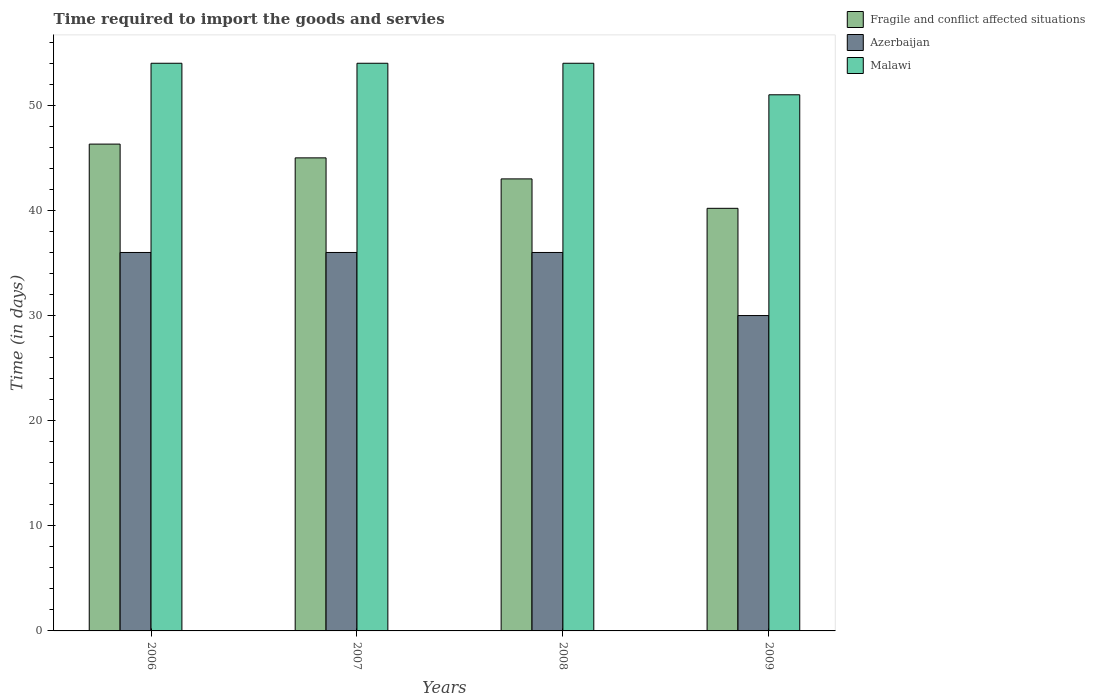How many groups of bars are there?
Provide a succinct answer. 4. Are the number of bars per tick equal to the number of legend labels?
Your answer should be very brief. Yes. How many bars are there on the 4th tick from the left?
Your response must be concise. 3. What is the label of the 1st group of bars from the left?
Your answer should be very brief. 2006. Across all years, what is the maximum number of days required to import the goods and services in Malawi?
Offer a terse response. 54. Across all years, what is the minimum number of days required to import the goods and services in Azerbaijan?
Give a very brief answer. 30. In which year was the number of days required to import the goods and services in Fragile and conflict affected situations maximum?
Offer a very short reply. 2006. What is the total number of days required to import the goods and services in Malawi in the graph?
Keep it short and to the point. 213. What is the difference between the number of days required to import the goods and services in Fragile and conflict affected situations in 2006 and that in 2007?
Provide a short and direct response. 1.31. What is the difference between the number of days required to import the goods and services in Fragile and conflict affected situations in 2009 and the number of days required to import the goods and services in Azerbaijan in 2006?
Your answer should be very brief. 4.2. What is the average number of days required to import the goods and services in Azerbaijan per year?
Offer a very short reply. 34.5. In the year 2007, what is the difference between the number of days required to import the goods and services in Fragile and conflict affected situations and number of days required to import the goods and services in Malawi?
Keep it short and to the point. -9. Is the difference between the number of days required to import the goods and services in Fragile and conflict affected situations in 2007 and 2008 greater than the difference between the number of days required to import the goods and services in Malawi in 2007 and 2008?
Your answer should be very brief. Yes. What is the difference between the highest and the second highest number of days required to import the goods and services in Fragile and conflict affected situations?
Offer a very short reply. 1.31. What is the difference between the highest and the lowest number of days required to import the goods and services in Malawi?
Provide a short and direct response. 3. What does the 3rd bar from the left in 2006 represents?
Give a very brief answer. Malawi. What does the 1st bar from the right in 2007 represents?
Make the answer very short. Malawi. Is it the case that in every year, the sum of the number of days required to import the goods and services in Malawi and number of days required to import the goods and services in Fragile and conflict affected situations is greater than the number of days required to import the goods and services in Azerbaijan?
Provide a succinct answer. Yes. How many bars are there?
Ensure brevity in your answer.  12. How many years are there in the graph?
Offer a terse response. 4. What is the difference between two consecutive major ticks on the Y-axis?
Keep it short and to the point. 10. Are the values on the major ticks of Y-axis written in scientific E-notation?
Provide a succinct answer. No. Does the graph contain grids?
Ensure brevity in your answer.  No. Where does the legend appear in the graph?
Your response must be concise. Top right. How are the legend labels stacked?
Offer a very short reply. Vertical. What is the title of the graph?
Make the answer very short. Time required to import the goods and servies. What is the label or title of the X-axis?
Your answer should be very brief. Years. What is the label or title of the Y-axis?
Provide a succinct answer. Time (in days). What is the Time (in days) in Fragile and conflict affected situations in 2006?
Provide a succinct answer. 46.31. What is the Time (in days) of Azerbaijan in 2006?
Provide a succinct answer. 36. What is the Time (in days) in Azerbaijan in 2007?
Ensure brevity in your answer.  36. What is the Time (in days) in Fragile and conflict affected situations in 2009?
Your answer should be very brief. 40.2. What is the Time (in days) of Malawi in 2009?
Your answer should be very brief. 51. Across all years, what is the maximum Time (in days) in Fragile and conflict affected situations?
Make the answer very short. 46.31. Across all years, what is the maximum Time (in days) of Azerbaijan?
Provide a succinct answer. 36. Across all years, what is the maximum Time (in days) in Malawi?
Make the answer very short. 54. Across all years, what is the minimum Time (in days) of Fragile and conflict affected situations?
Make the answer very short. 40.2. Across all years, what is the minimum Time (in days) of Malawi?
Provide a succinct answer. 51. What is the total Time (in days) in Fragile and conflict affected situations in the graph?
Provide a succinct answer. 174.51. What is the total Time (in days) in Azerbaijan in the graph?
Your answer should be compact. 138. What is the total Time (in days) in Malawi in the graph?
Offer a very short reply. 213. What is the difference between the Time (in days) of Fragile and conflict affected situations in 2006 and that in 2007?
Your response must be concise. 1.31. What is the difference between the Time (in days) of Fragile and conflict affected situations in 2006 and that in 2008?
Keep it short and to the point. 3.31. What is the difference between the Time (in days) of Azerbaijan in 2006 and that in 2008?
Ensure brevity in your answer.  0. What is the difference between the Time (in days) of Fragile and conflict affected situations in 2006 and that in 2009?
Offer a very short reply. 6.11. What is the difference between the Time (in days) of Azerbaijan in 2006 and that in 2009?
Your response must be concise. 6. What is the difference between the Time (in days) in Malawi in 2006 and that in 2009?
Give a very brief answer. 3. What is the difference between the Time (in days) of Azerbaijan in 2007 and that in 2008?
Offer a terse response. 0. What is the difference between the Time (in days) in Fragile and conflict affected situations in 2007 and that in 2009?
Your response must be concise. 4.8. What is the difference between the Time (in days) in Fragile and conflict affected situations in 2008 and that in 2009?
Offer a terse response. 2.8. What is the difference between the Time (in days) of Azerbaijan in 2008 and that in 2009?
Offer a terse response. 6. What is the difference between the Time (in days) of Malawi in 2008 and that in 2009?
Ensure brevity in your answer.  3. What is the difference between the Time (in days) in Fragile and conflict affected situations in 2006 and the Time (in days) in Azerbaijan in 2007?
Offer a very short reply. 10.31. What is the difference between the Time (in days) in Fragile and conflict affected situations in 2006 and the Time (in days) in Malawi in 2007?
Provide a succinct answer. -7.69. What is the difference between the Time (in days) in Fragile and conflict affected situations in 2006 and the Time (in days) in Azerbaijan in 2008?
Provide a succinct answer. 10.31. What is the difference between the Time (in days) of Fragile and conflict affected situations in 2006 and the Time (in days) of Malawi in 2008?
Offer a terse response. -7.69. What is the difference between the Time (in days) of Fragile and conflict affected situations in 2006 and the Time (in days) of Azerbaijan in 2009?
Make the answer very short. 16.31. What is the difference between the Time (in days) in Fragile and conflict affected situations in 2006 and the Time (in days) in Malawi in 2009?
Provide a short and direct response. -4.69. What is the difference between the Time (in days) of Fragile and conflict affected situations in 2007 and the Time (in days) of Malawi in 2008?
Offer a terse response. -9. What is the difference between the Time (in days) in Azerbaijan in 2007 and the Time (in days) in Malawi in 2008?
Make the answer very short. -18. What is the difference between the Time (in days) in Fragile and conflict affected situations in 2007 and the Time (in days) in Azerbaijan in 2009?
Give a very brief answer. 15. What is the difference between the Time (in days) of Fragile and conflict affected situations in 2007 and the Time (in days) of Malawi in 2009?
Your response must be concise. -6. What is the difference between the Time (in days) in Azerbaijan in 2007 and the Time (in days) in Malawi in 2009?
Provide a short and direct response. -15. What is the difference between the Time (in days) in Fragile and conflict affected situations in 2008 and the Time (in days) in Azerbaijan in 2009?
Keep it short and to the point. 13. What is the difference between the Time (in days) in Fragile and conflict affected situations in 2008 and the Time (in days) in Malawi in 2009?
Provide a short and direct response. -8. What is the average Time (in days) in Fragile and conflict affected situations per year?
Provide a short and direct response. 43.63. What is the average Time (in days) in Azerbaijan per year?
Your answer should be compact. 34.5. What is the average Time (in days) of Malawi per year?
Offer a terse response. 53.25. In the year 2006, what is the difference between the Time (in days) in Fragile and conflict affected situations and Time (in days) in Azerbaijan?
Offer a very short reply. 10.31. In the year 2006, what is the difference between the Time (in days) of Fragile and conflict affected situations and Time (in days) of Malawi?
Offer a terse response. -7.69. In the year 2007, what is the difference between the Time (in days) of Fragile and conflict affected situations and Time (in days) of Malawi?
Make the answer very short. -9. In the year 2008, what is the difference between the Time (in days) of Fragile and conflict affected situations and Time (in days) of Azerbaijan?
Ensure brevity in your answer.  7. In the year 2008, what is the difference between the Time (in days) of Azerbaijan and Time (in days) of Malawi?
Make the answer very short. -18. In the year 2009, what is the difference between the Time (in days) of Fragile and conflict affected situations and Time (in days) of Azerbaijan?
Keep it short and to the point. 10.2. What is the ratio of the Time (in days) of Fragile and conflict affected situations in 2006 to that in 2007?
Provide a succinct answer. 1.03. What is the ratio of the Time (in days) in Azerbaijan in 2006 to that in 2007?
Give a very brief answer. 1. What is the ratio of the Time (in days) of Fragile and conflict affected situations in 2006 to that in 2008?
Offer a very short reply. 1.08. What is the ratio of the Time (in days) in Fragile and conflict affected situations in 2006 to that in 2009?
Provide a short and direct response. 1.15. What is the ratio of the Time (in days) in Malawi in 2006 to that in 2009?
Your response must be concise. 1.06. What is the ratio of the Time (in days) in Fragile and conflict affected situations in 2007 to that in 2008?
Offer a very short reply. 1.05. What is the ratio of the Time (in days) in Malawi in 2007 to that in 2008?
Offer a very short reply. 1. What is the ratio of the Time (in days) in Fragile and conflict affected situations in 2007 to that in 2009?
Your answer should be very brief. 1.12. What is the ratio of the Time (in days) of Azerbaijan in 2007 to that in 2009?
Offer a very short reply. 1.2. What is the ratio of the Time (in days) of Malawi in 2007 to that in 2009?
Ensure brevity in your answer.  1.06. What is the ratio of the Time (in days) in Fragile and conflict affected situations in 2008 to that in 2009?
Offer a very short reply. 1.07. What is the ratio of the Time (in days) in Azerbaijan in 2008 to that in 2009?
Offer a very short reply. 1.2. What is the ratio of the Time (in days) of Malawi in 2008 to that in 2009?
Ensure brevity in your answer.  1.06. What is the difference between the highest and the second highest Time (in days) of Fragile and conflict affected situations?
Keep it short and to the point. 1.31. What is the difference between the highest and the second highest Time (in days) in Azerbaijan?
Offer a very short reply. 0. What is the difference between the highest and the lowest Time (in days) of Fragile and conflict affected situations?
Provide a succinct answer. 6.11. What is the difference between the highest and the lowest Time (in days) in Azerbaijan?
Offer a terse response. 6. What is the difference between the highest and the lowest Time (in days) of Malawi?
Ensure brevity in your answer.  3. 